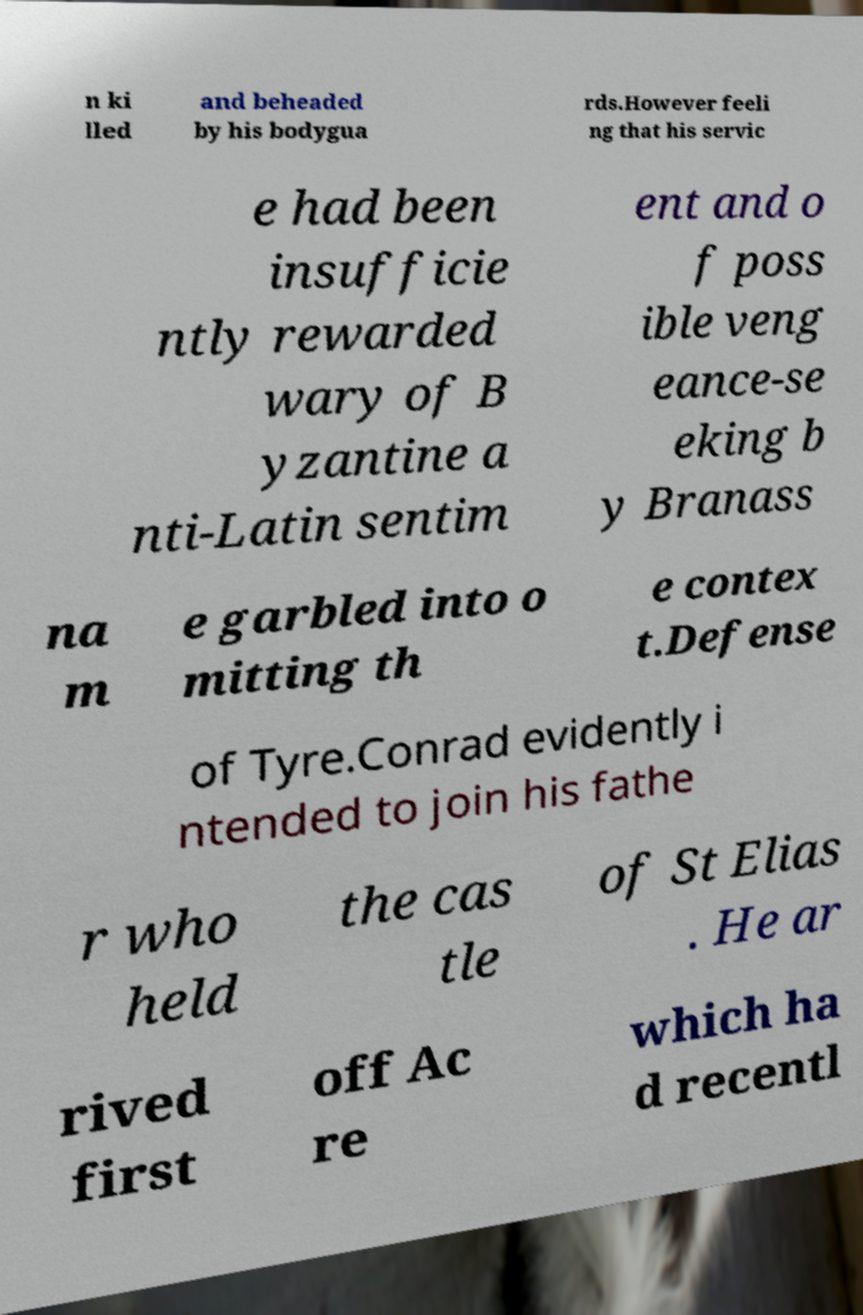I need the written content from this picture converted into text. Can you do that? n ki lled and beheaded by his bodygua rds.However feeli ng that his servic e had been insufficie ntly rewarded wary of B yzantine a nti-Latin sentim ent and o f poss ible veng eance-se eking b y Branass na m e garbled into o mitting th e contex t.Defense of Tyre.Conrad evidently i ntended to join his fathe r who held the cas tle of St Elias . He ar rived first off Ac re which ha d recentl 